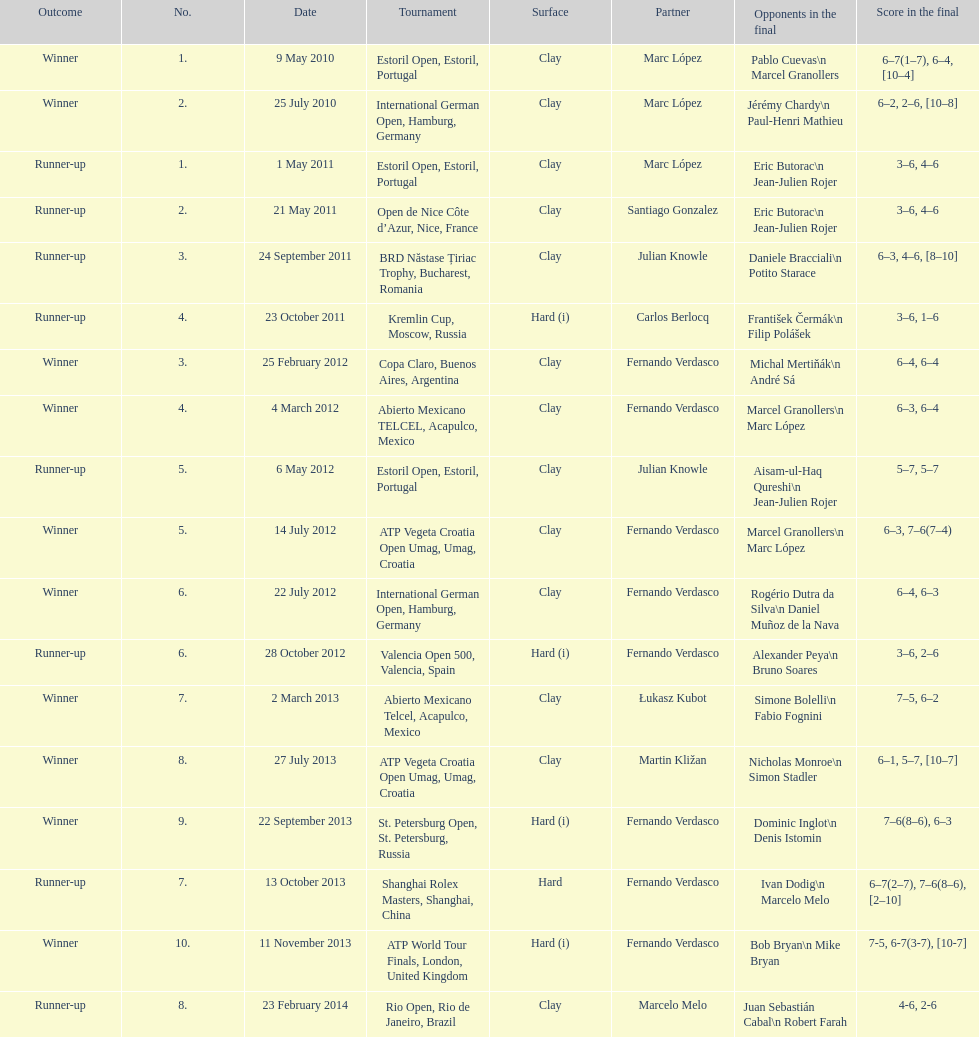How many second-place finishers are listed at most? 8. 